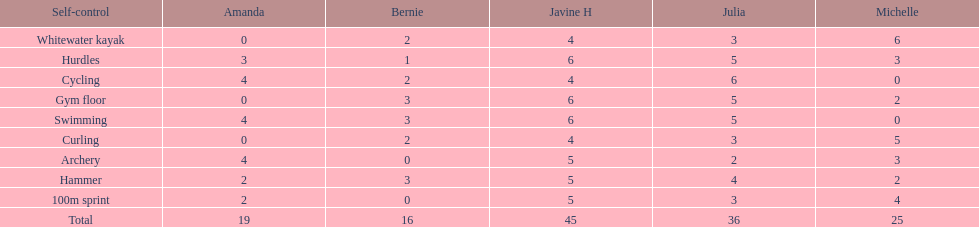Who is the faster runner? Javine H. 